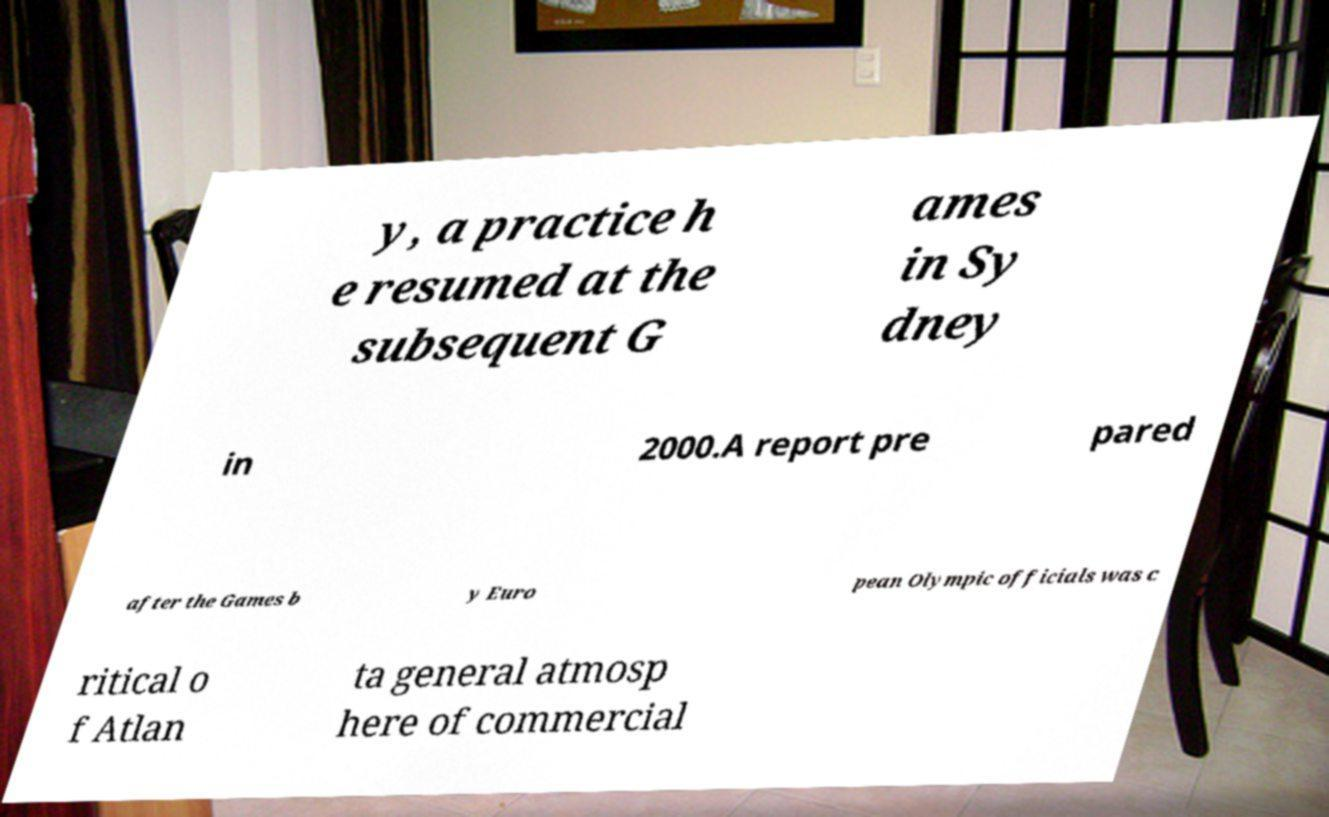There's text embedded in this image that I need extracted. Can you transcribe it verbatim? y, a practice h e resumed at the subsequent G ames in Sy dney in 2000.A report pre pared after the Games b y Euro pean Olympic officials was c ritical o f Atlan ta general atmosp here of commercial 